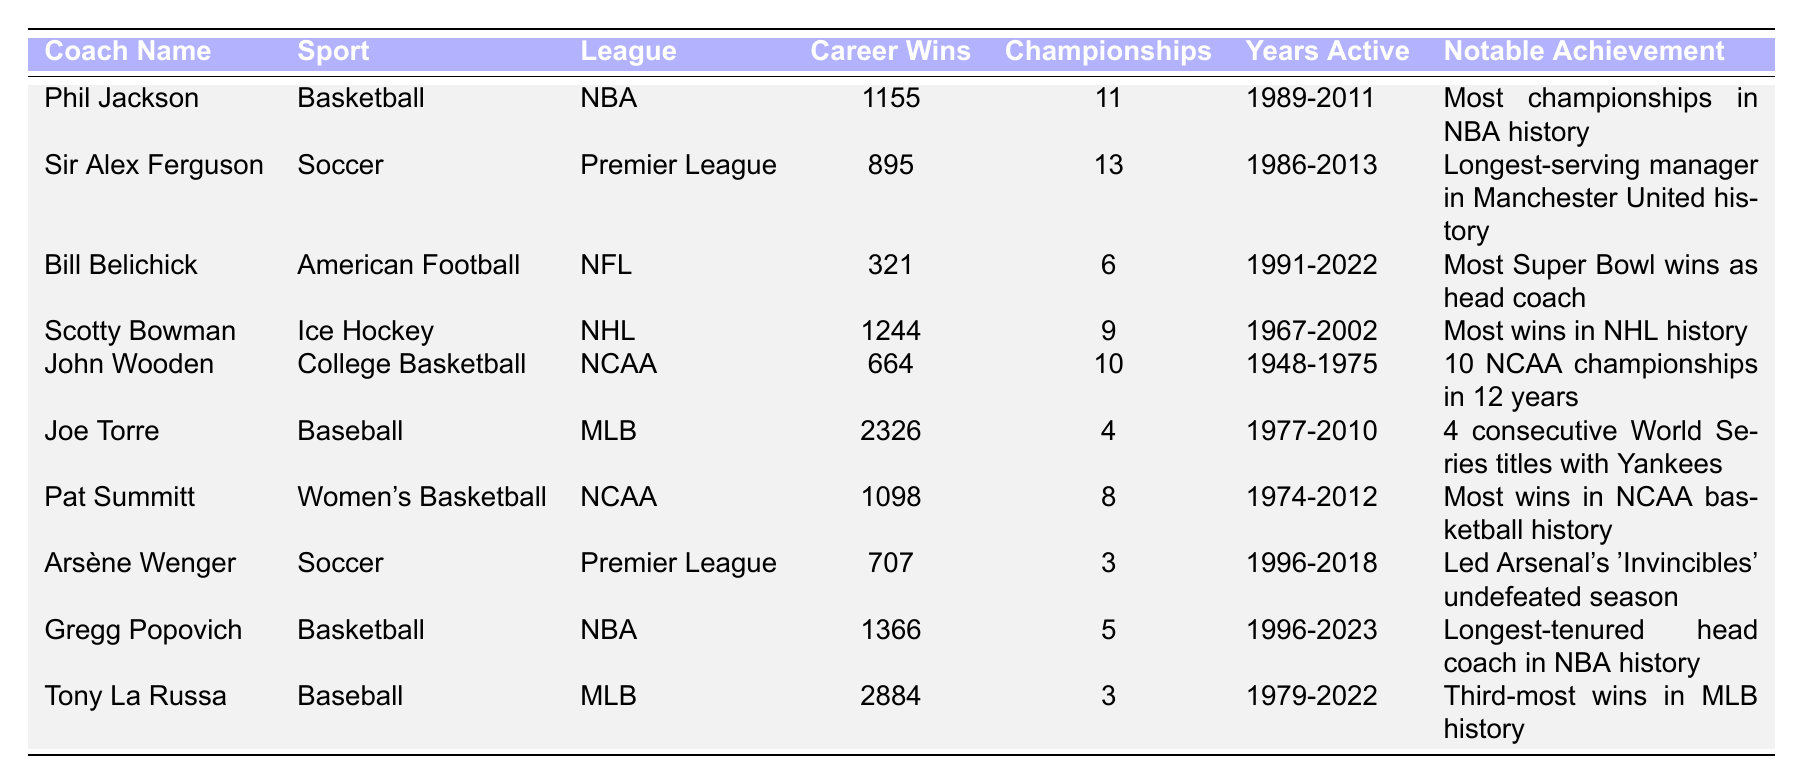What is the total number of championships won by Phil Jackson and Scotty Bowman combined? Phil Jackson has 11 championships and Scotty Bowman has 9 championships. Adding them together: 11 + 9 = 20.
Answer: 20 Which coach has the most career wins in the table? By reviewing the 'Career Wins' column, Joe Torre has the highest total with 2326 wins.
Answer: Joe Torre Did Arsène Wenger win more than 3 championships? Arsène Wenger won 3 championships. Therefore, it is not true that he won more than 3.
Answer: No How many years did Pat Summitt actively coach? Pat Summitt was active for 38 years, from 1974 to 2012. This can be calculated by subtracting the starting year from the ending year: 2012 - 1974 = 38.
Answer: 38 Which sport did John Wooden coach in? John Wooden coached college basketball, as indicated in the 'Sport' column.
Answer: College Basketball What is the average number of championships won by the coaches listed in the table? Adding the total championships: 11 + 13 + 6 + 9 + 10 + 4 + 8 + 3 + 5 + 3 = 72 championships. There are 10 coaches, so the average is 72 / 10 = 7.2.
Answer: 7.2 Is it true that Bill Belichick has more career wins than John Wooden? Bill Belichick has 321 career wins, while John Wooden has 664. This means that Bill Belichick has fewer wins than John Wooden.
Answer: No Which two coaches have the longest coaching tenure, and what is the difference in their active years? Phil Jackson was active from 1989 to 2011 (22 years), and Joe Torre was active from 1977 to 2010 (33 years). The difference in their active years is 33 - 22 = 11 years.
Answer: 11 years What notable achievement is associated with Gregg Popovich? The notable achievement for Gregg Popovich is that he is the longest-tenured head coach in NBA history. This is detailed in the 'Notable Achievement' column.
Answer: Longest-tenured head coach in NBA history 